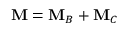<formula> <loc_0><loc_0><loc_500><loc_500>M = M _ { B } + M _ { C }</formula> 